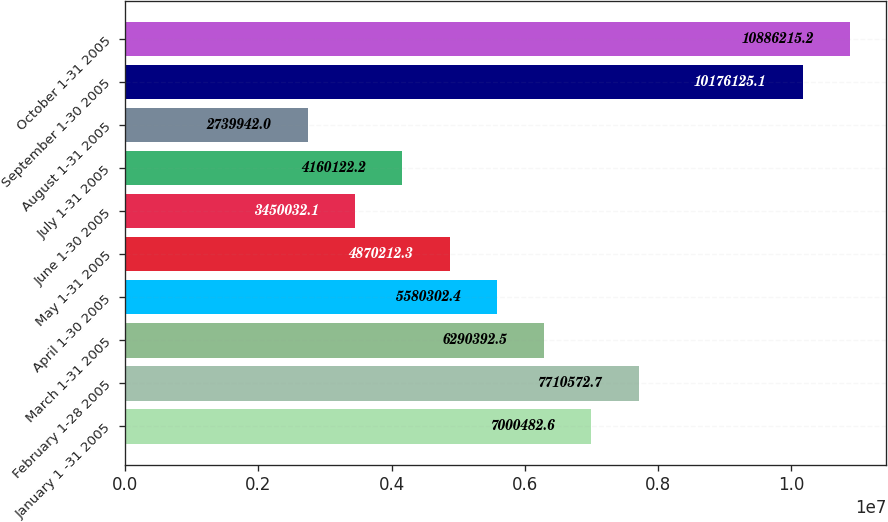<chart> <loc_0><loc_0><loc_500><loc_500><bar_chart><fcel>January 1 -31 2005<fcel>February 1-28 2005<fcel>March 1-31 2005<fcel>April 1-30 2005<fcel>May 1-31 2005<fcel>June 1-30 2005<fcel>July 1-31 2005<fcel>August 1-31 2005<fcel>September 1-30 2005<fcel>October 1-31 2005<nl><fcel>7.00048e+06<fcel>7.71057e+06<fcel>6.29039e+06<fcel>5.5803e+06<fcel>4.87021e+06<fcel>3.45003e+06<fcel>4.16012e+06<fcel>2.73994e+06<fcel>1.01761e+07<fcel>1.08862e+07<nl></chart> 